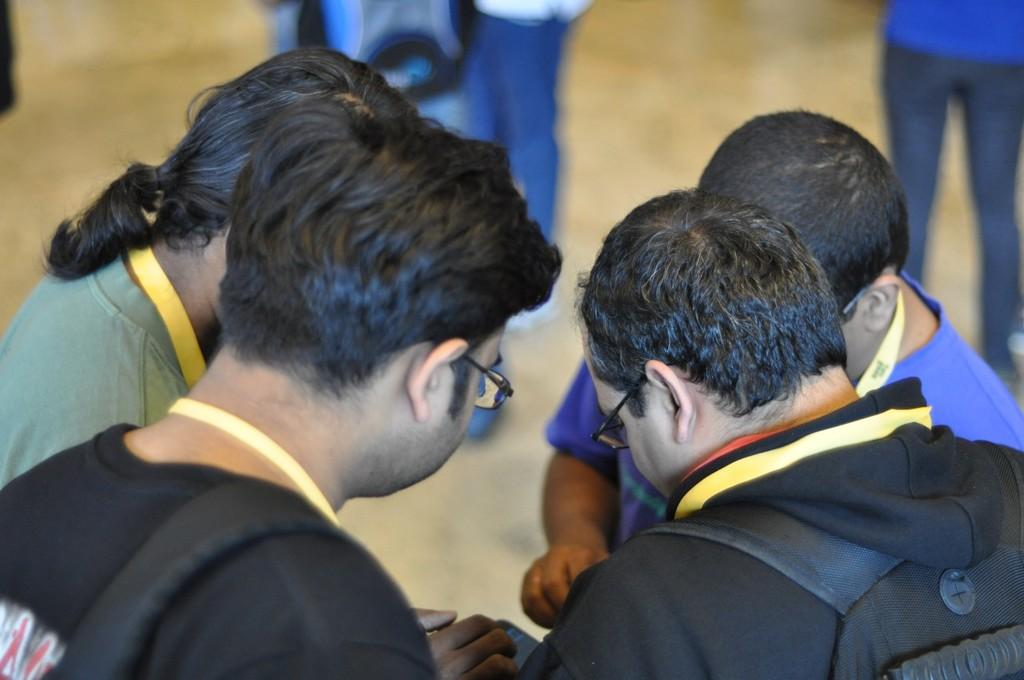What is the main subject of the image? The main subject of the image is a group of people. What are the people in the image doing? The people are standing. How can we differentiate the people in the image? The people are wearing different color dresses. What effect does the route have on the people in the image? There is no mention of a route in the image, so it's not possible to determine any effect it might have on the people. 